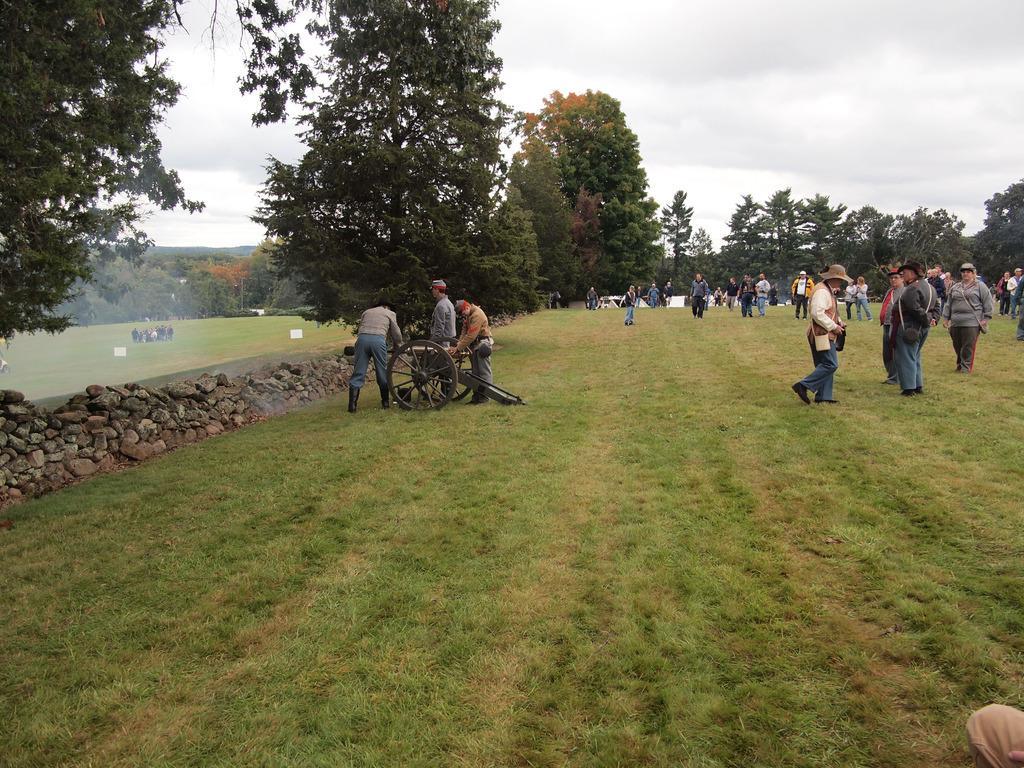Describe this image in one or two sentences. In the image there are many people standing and walking on the grassland and on the left side there is a stone wall, in the back ground there are trees and above its sky with clouds. 